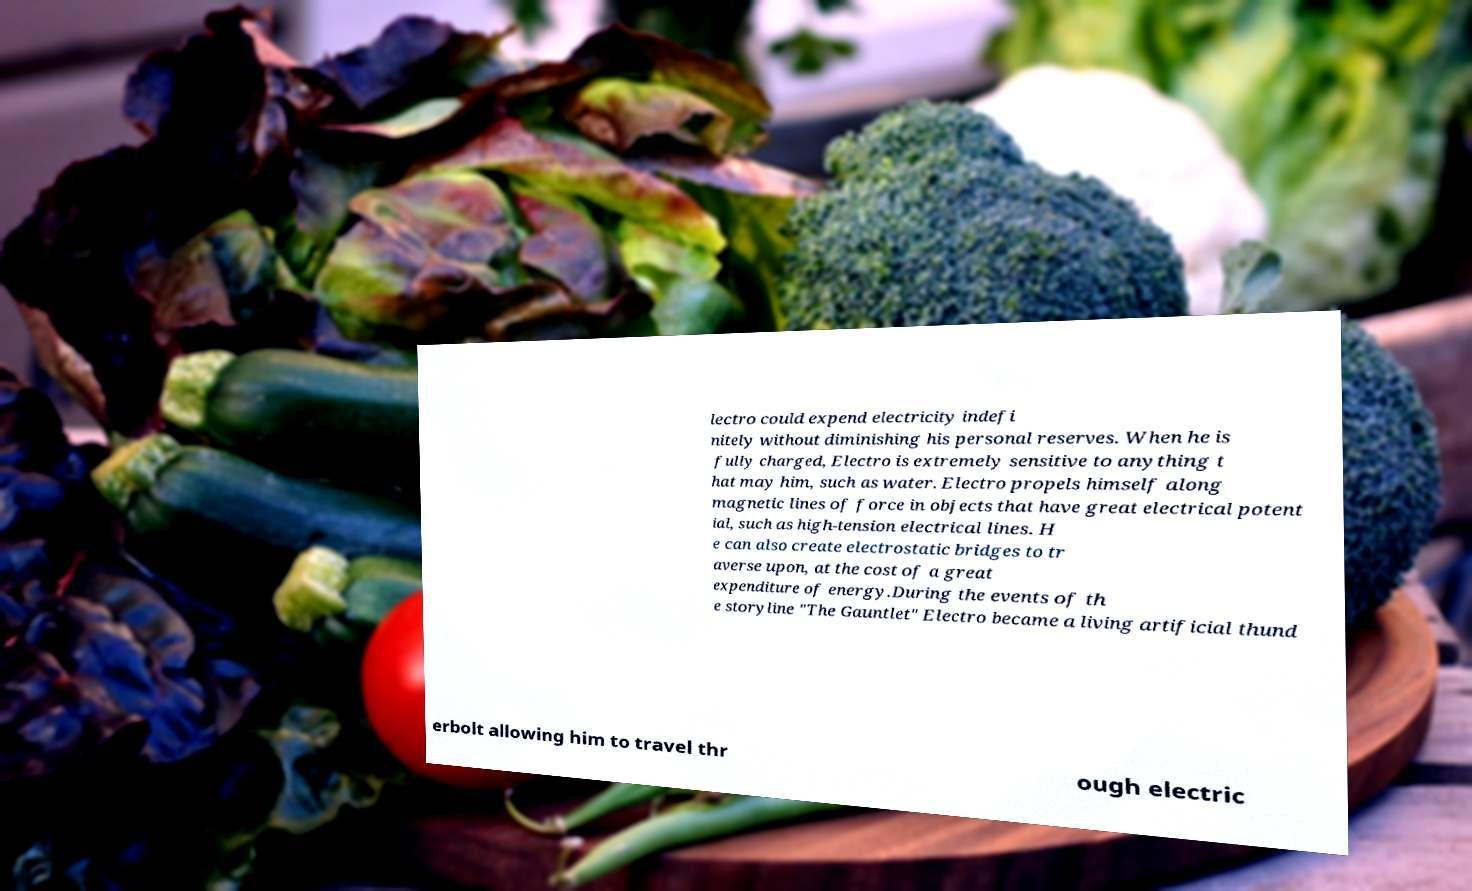Please read and relay the text visible in this image. What does it say? lectro could expend electricity indefi nitely without diminishing his personal reserves. When he is fully charged, Electro is extremely sensitive to anything t hat may him, such as water. Electro propels himself along magnetic lines of force in objects that have great electrical potent ial, such as high-tension electrical lines. H e can also create electrostatic bridges to tr averse upon, at the cost of a great expenditure of energy.During the events of th e storyline "The Gauntlet" Electro became a living artificial thund erbolt allowing him to travel thr ough electric 